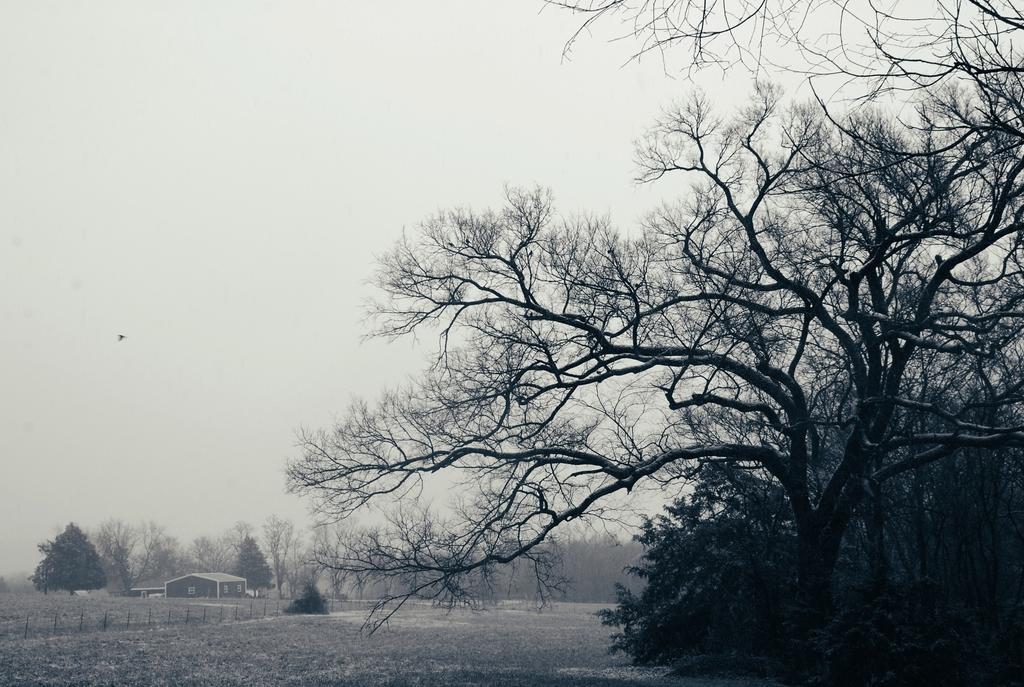Describe this image in one or two sentences. In this image I can see few trees, the ground and the fencing. In the background I can see a building, few trees and the sky. 